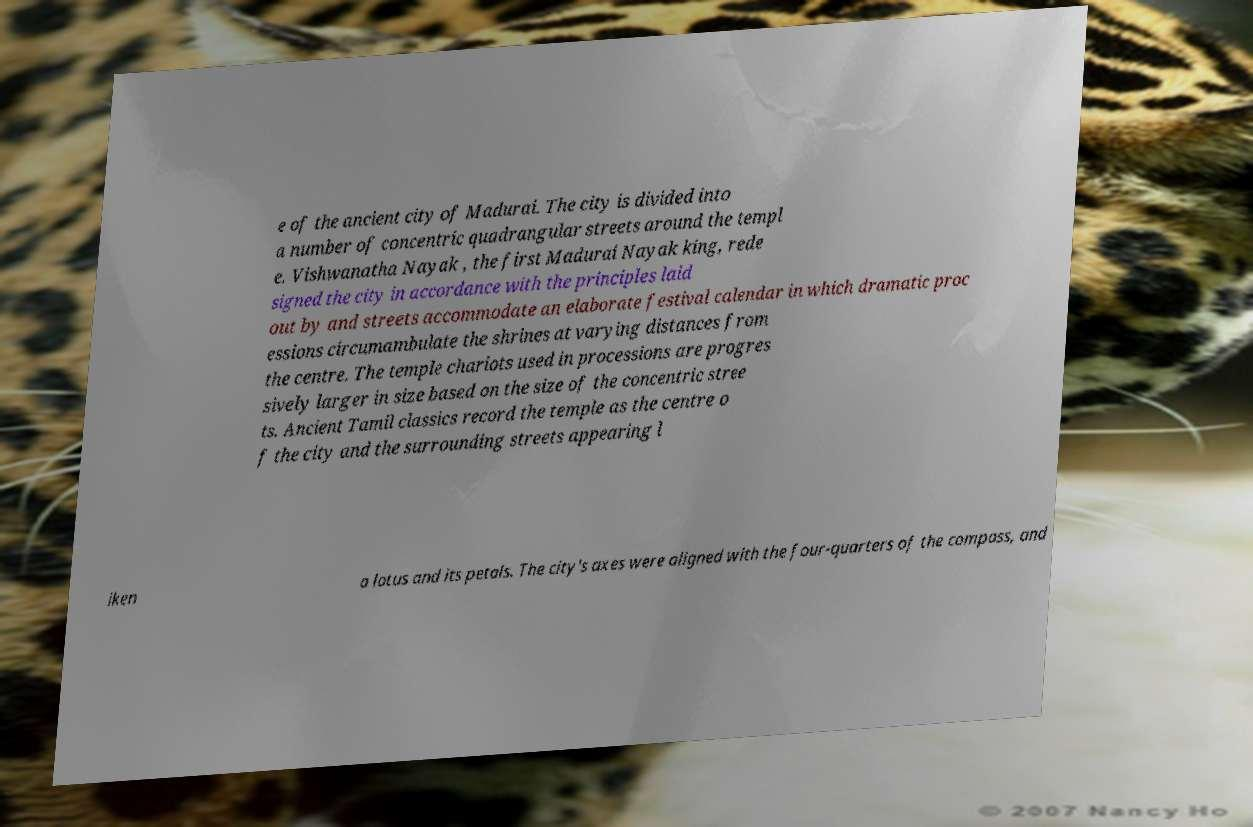Please identify and transcribe the text found in this image. e of the ancient city of Madurai. The city is divided into a number of concentric quadrangular streets around the templ e. Vishwanatha Nayak , the first Madurai Nayak king, rede signed the city in accordance with the principles laid out by and streets accommodate an elaborate festival calendar in which dramatic proc essions circumambulate the shrines at varying distances from the centre. The temple chariots used in processions are progres sively larger in size based on the size of the concentric stree ts. Ancient Tamil classics record the temple as the centre o f the city and the surrounding streets appearing l iken a lotus and its petals. The city's axes were aligned with the four-quarters of the compass, and 